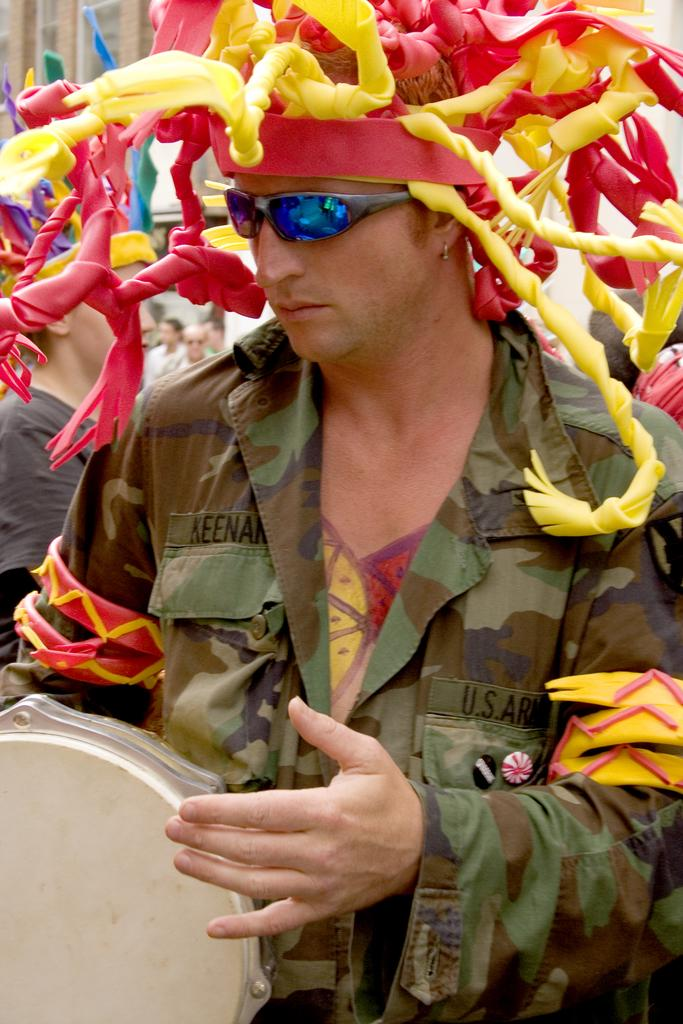What is the main subject of the image? The main subject of the image is a man. What is the man wearing in the image? The man is wearing a hat in the image. What is the man doing in the image? The man is playing a musical instrument in the image. What can be seen in the background of the image? There are people and a building in the background of the image. What type of food is the kitten eating in the image? There is no kitten or food present in the image. Is there a cake visible in the image? There is no cake present in the image. 